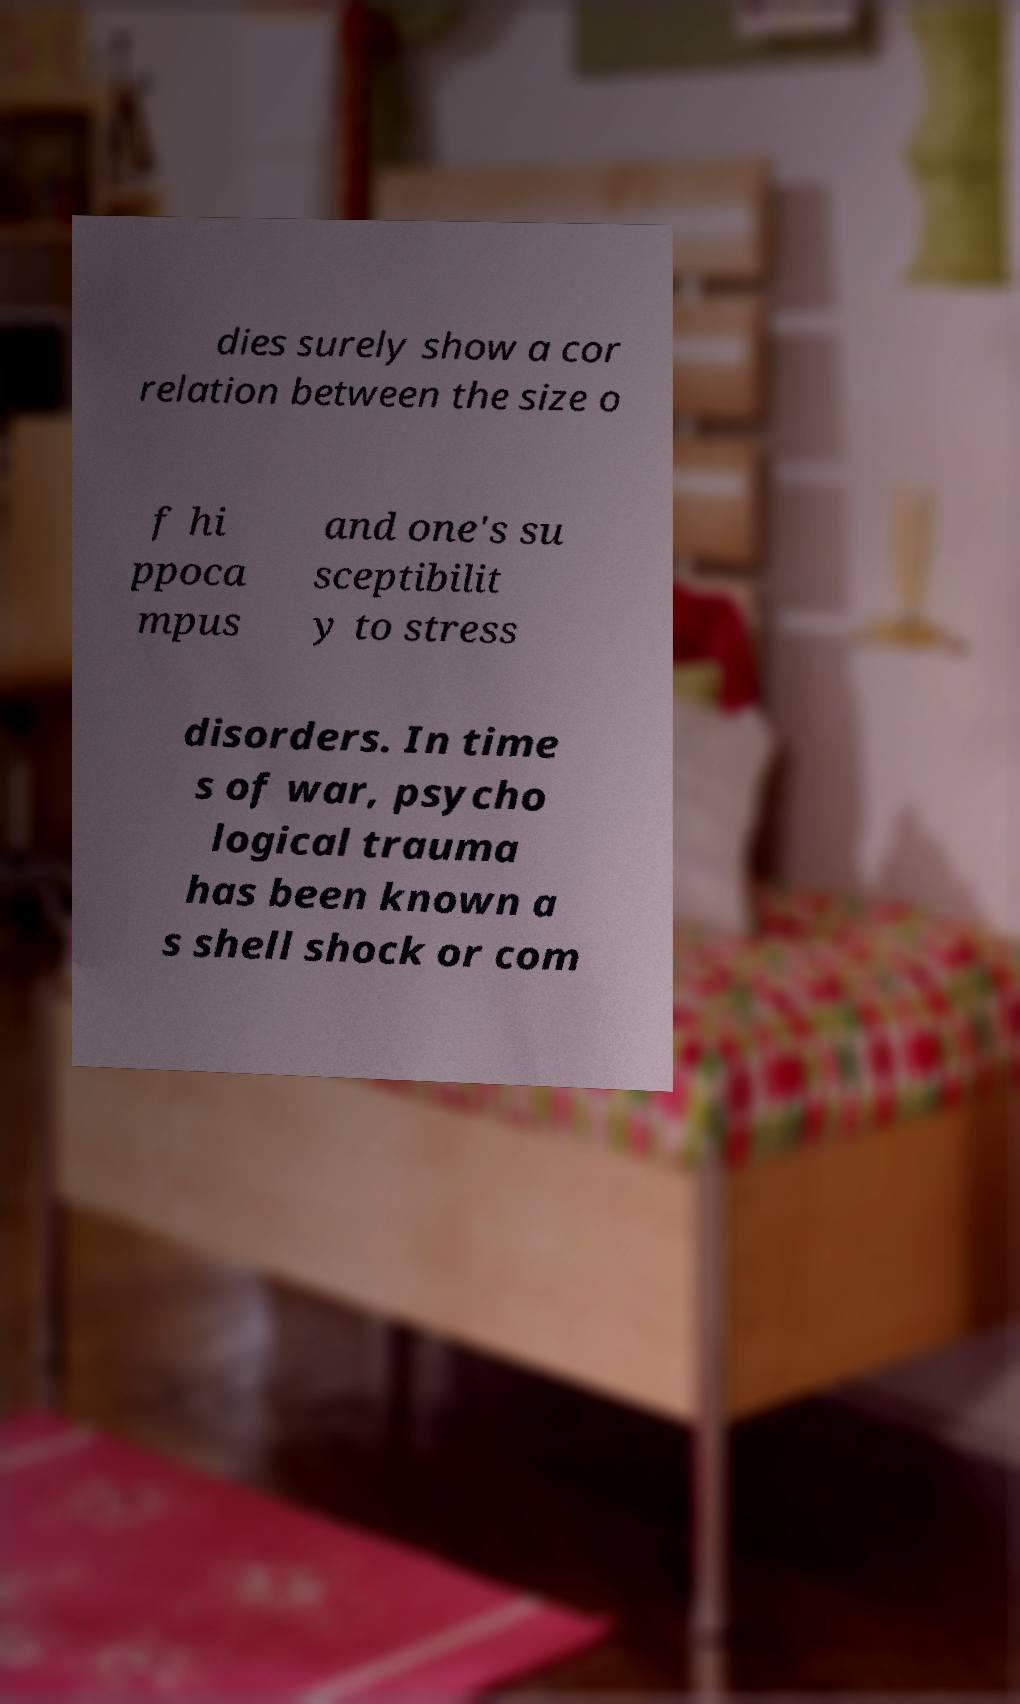Can you read and provide the text displayed in the image?This photo seems to have some interesting text. Can you extract and type it out for me? dies surely show a cor relation between the size o f hi ppoca mpus and one's su sceptibilit y to stress disorders. In time s of war, psycho logical trauma has been known a s shell shock or com 